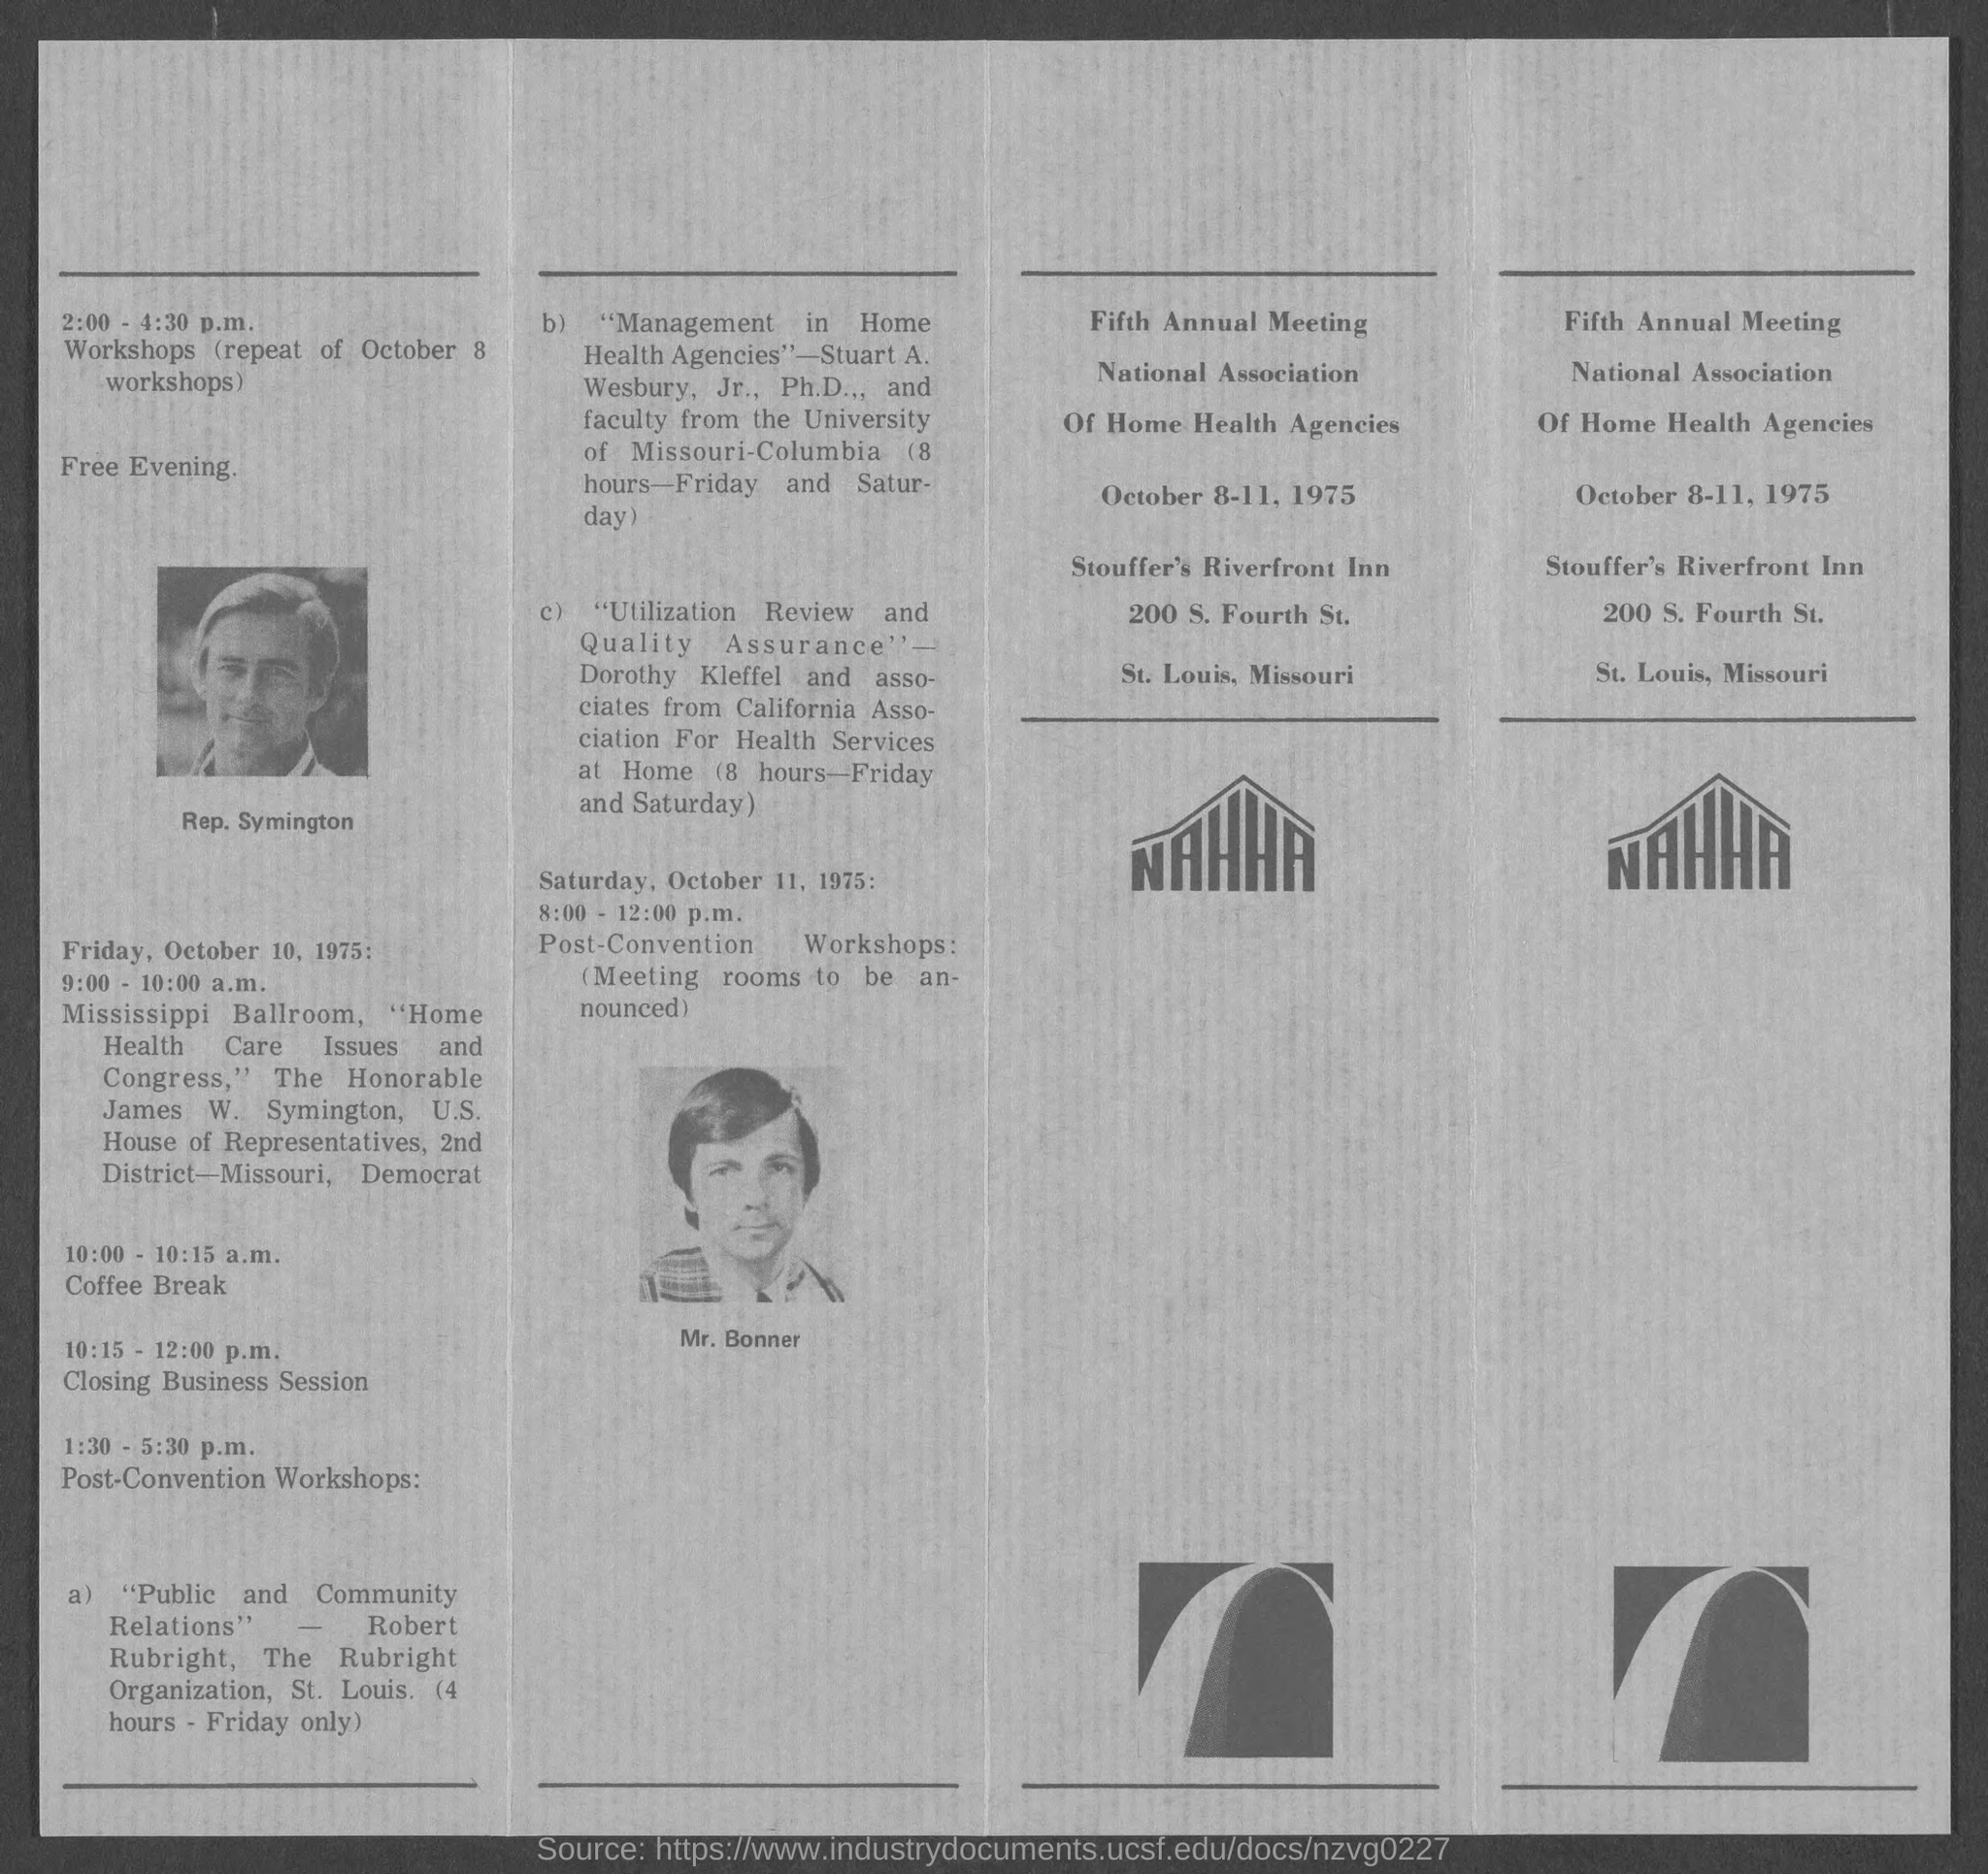In which state is stouffer's riverfront inn located ?
Provide a short and direct response. Missouri. 